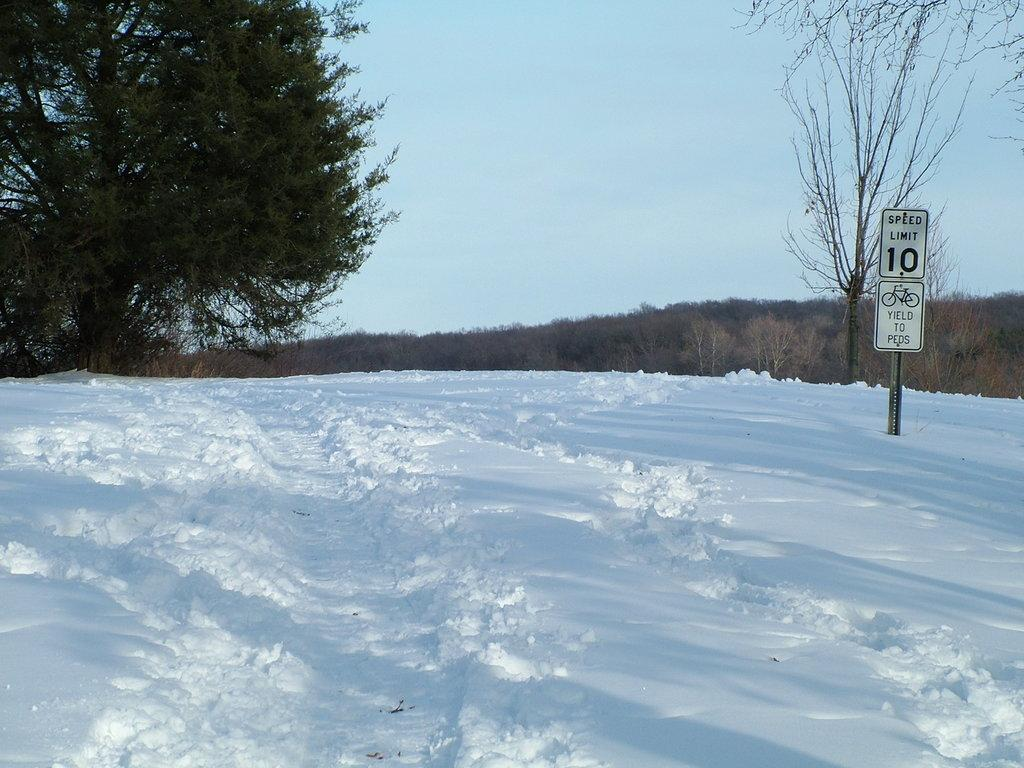What type of natural environment is depicted at the bottom of the image? There is snow at the bottom of the image. What can be seen in the background of the image? There are trees in the background of the image. What object is visible in the image? There is a board visible in the image. What is visible at the top of the image? The sky is visible at the top of the image. What type of game is being played on the board in the image? There is no game being played on the board in the image; it is just a plain board. Can you see a receipt on the board in the image? There is no receipt present on the board or anywhere else in the image. 